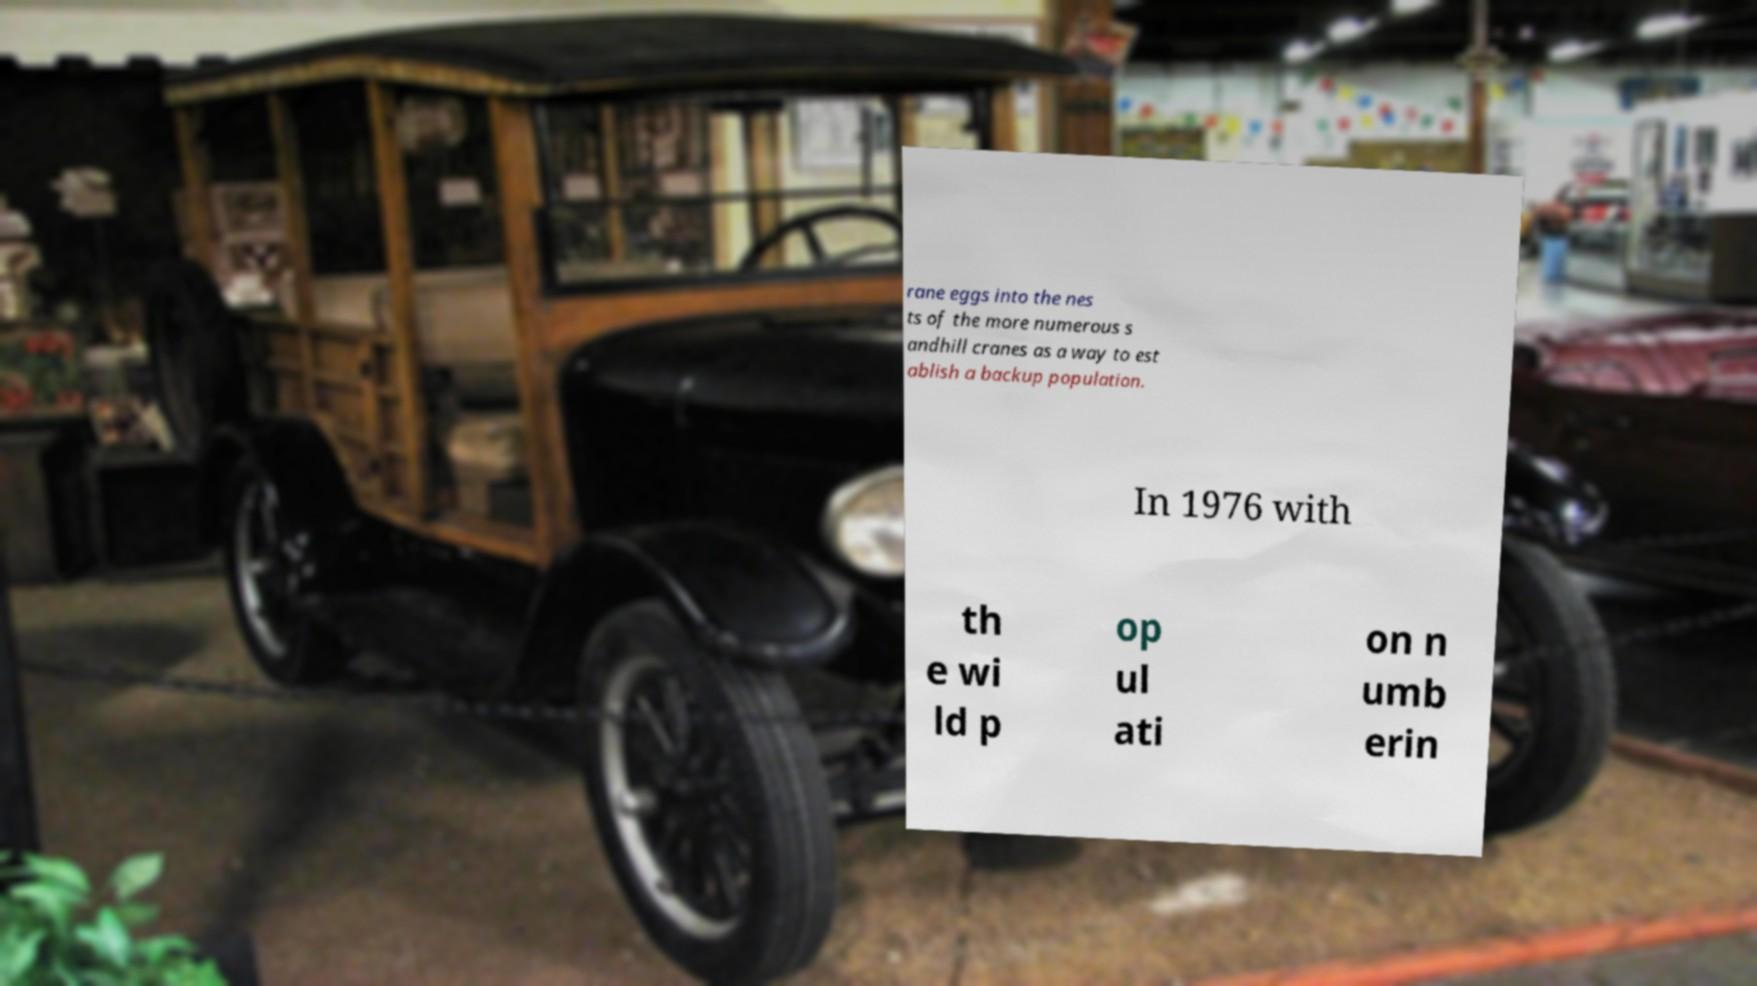Please read and relay the text visible in this image. What does it say? rane eggs into the nes ts of the more numerous s andhill cranes as a way to est ablish a backup population. In 1976 with th e wi ld p op ul ati on n umb erin 